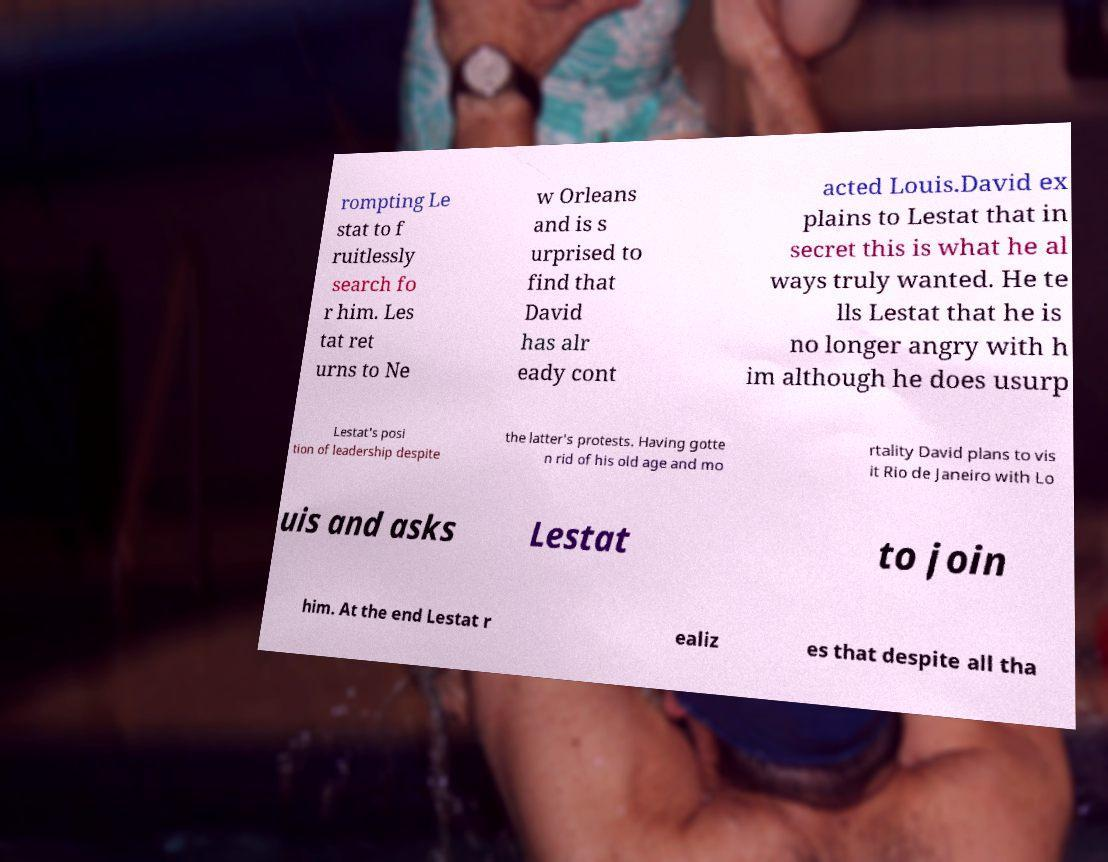Please identify and transcribe the text found in this image. rompting Le stat to f ruitlessly search fo r him. Les tat ret urns to Ne w Orleans and is s urprised to find that David has alr eady cont acted Louis.David ex plains to Lestat that in secret this is what he al ways truly wanted. He te lls Lestat that he is no longer angry with h im although he does usurp Lestat's posi tion of leadership despite the latter's protests. Having gotte n rid of his old age and mo rtality David plans to vis it Rio de Janeiro with Lo uis and asks Lestat to join him. At the end Lestat r ealiz es that despite all tha 